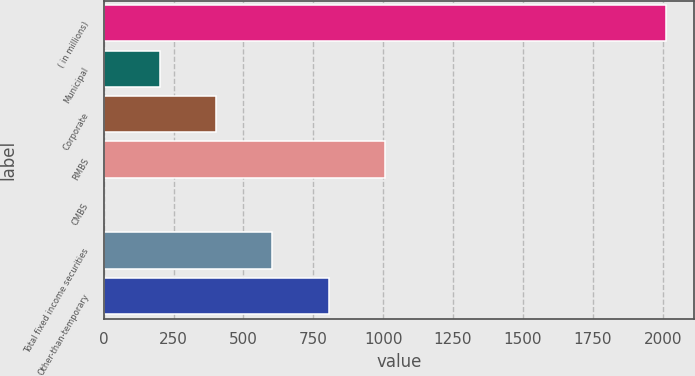Convert chart to OTSL. <chart><loc_0><loc_0><loc_500><loc_500><bar_chart><fcel>( in millions)<fcel>Municipal<fcel>Corporate<fcel>RMBS<fcel>CMBS<fcel>Total fixed income securities<fcel>Other-than-temporary<nl><fcel>2011<fcel>202<fcel>403<fcel>1006<fcel>1<fcel>604<fcel>805<nl></chart> 